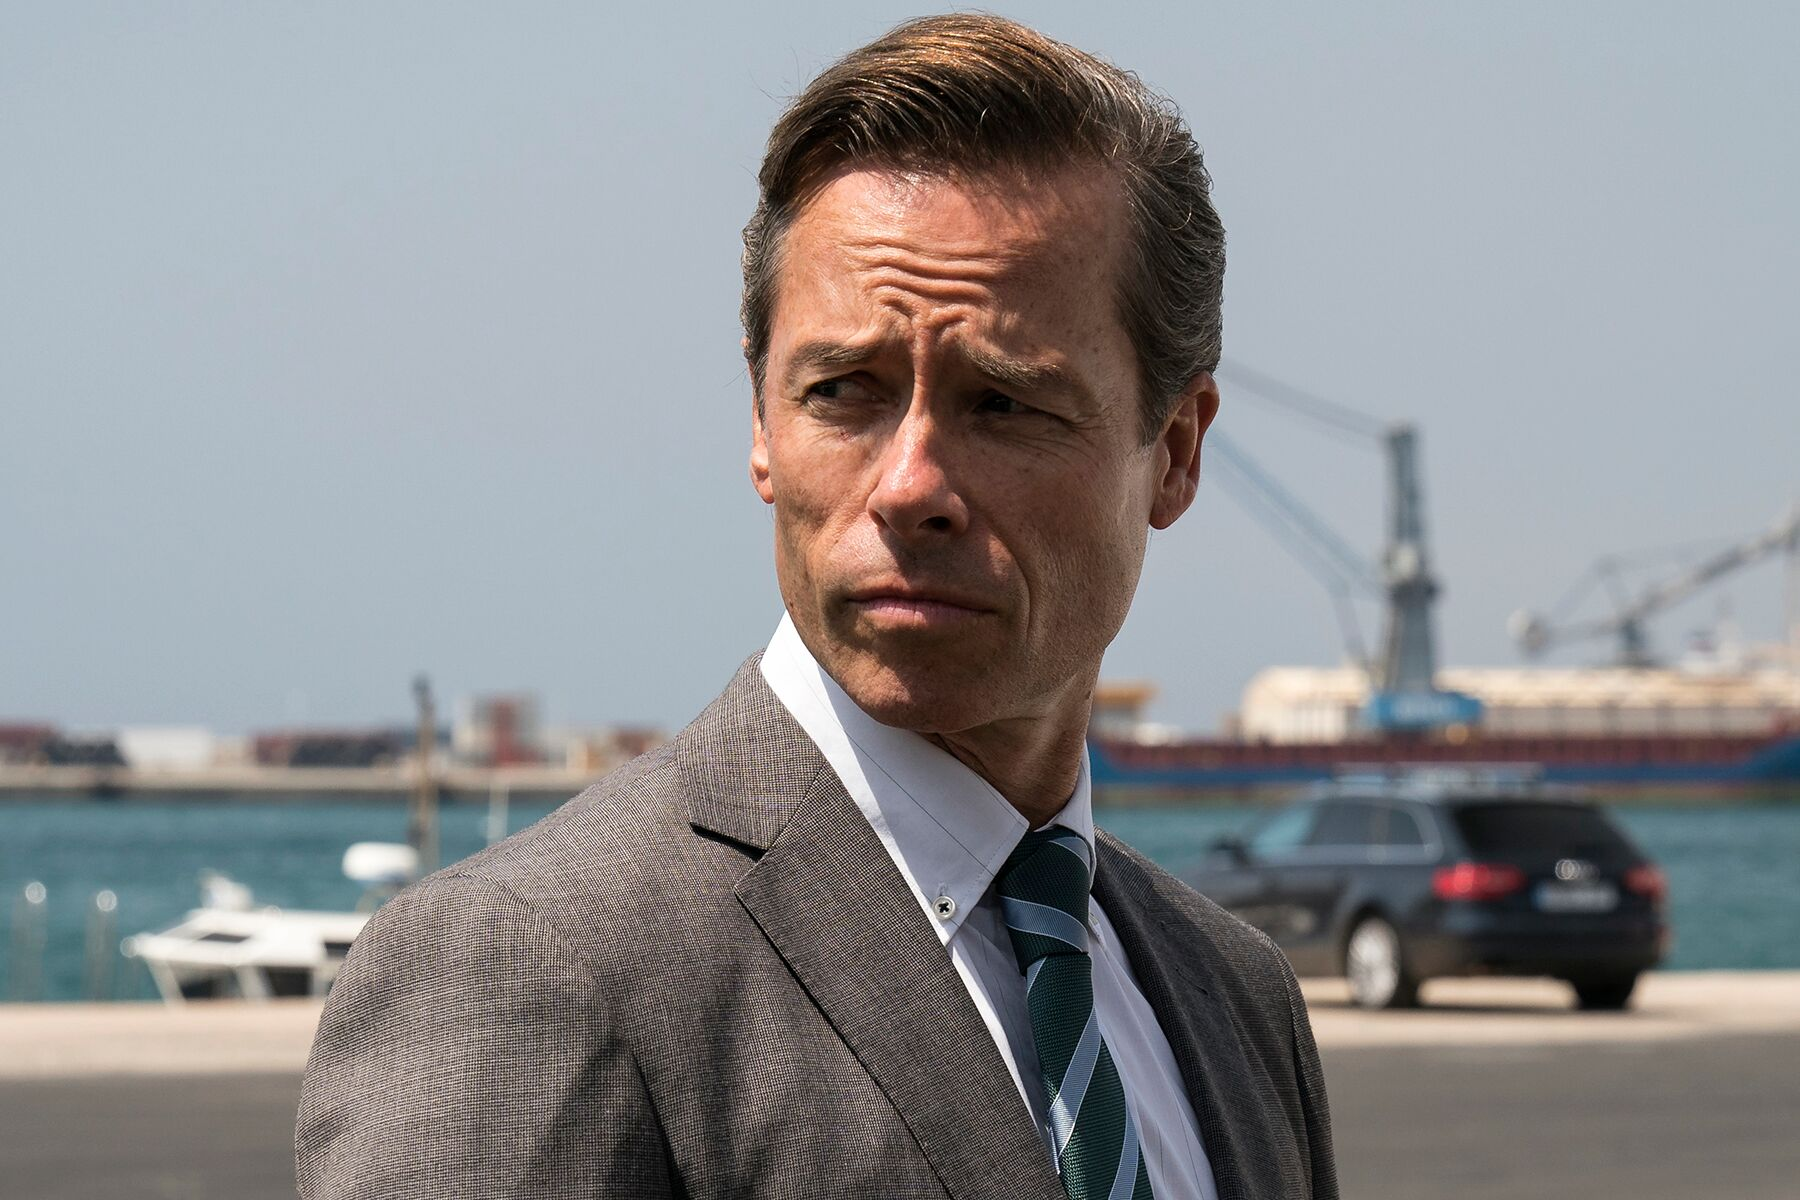What might this image symbolize about modern industry and leadership? This image can symbolize the juxtaposition of modern industry and the solemnity required in contemporary leadership roles. The man's professional attire against the backdrop of a bustling port exemplifies the intersection of human leadership and large-scale industrial operations. It highlights how modern leaders must constantly navigate complex environments, make strategic decisions, and manage both human and material resources meticulously. The serious expression suggests the weight of responsibility that comes with leadership, facing challenges head-on in a world where commerce, trade, and logistics play pivotal roles in driving progress. 